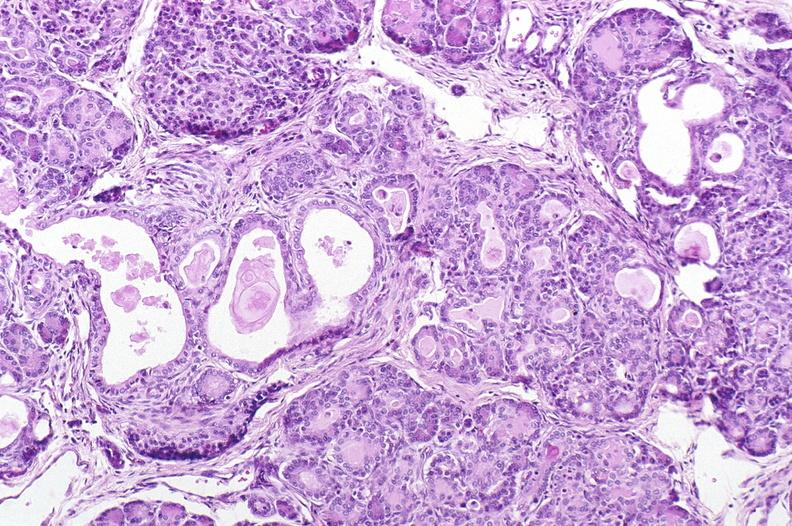s pancreas present?
Answer the question using a single word or phrase. Yes 